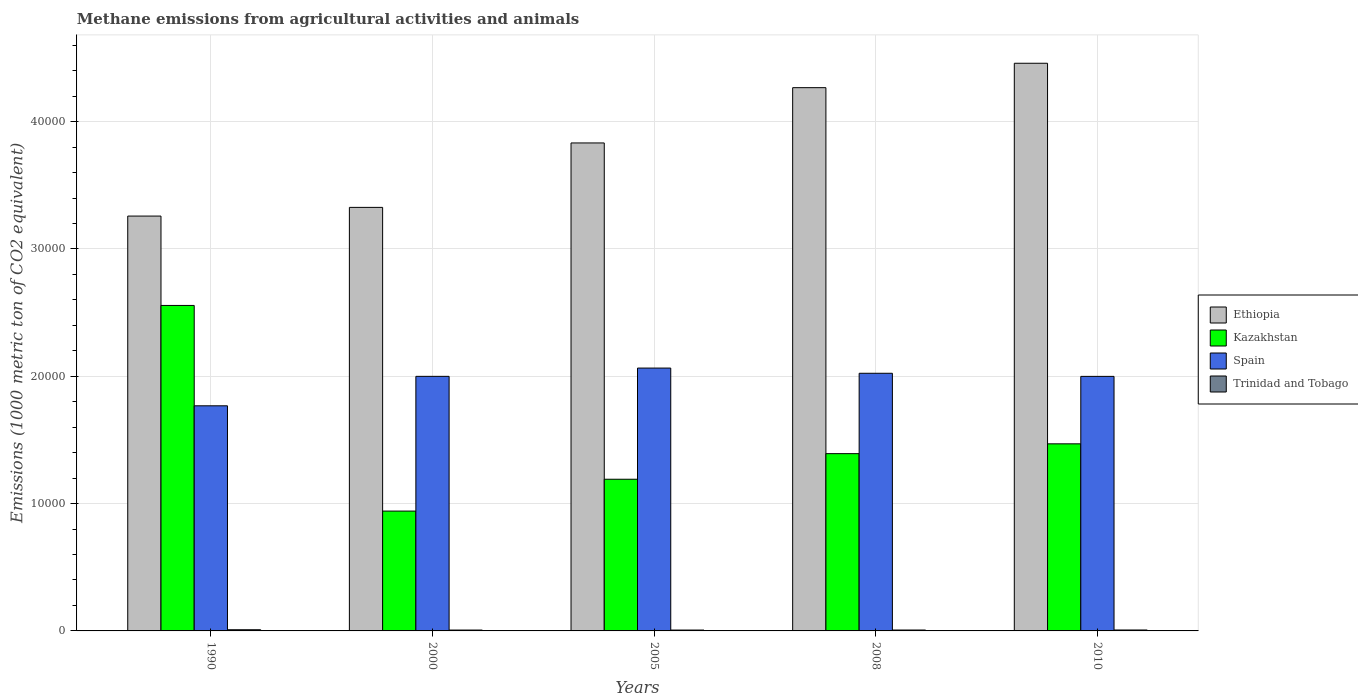Are the number of bars per tick equal to the number of legend labels?
Give a very brief answer. Yes. What is the label of the 5th group of bars from the left?
Offer a very short reply. 2010. What is the amount of methane emitted in Trinidad and Tobago in 2008?
Your answer should be very brief. 71. Across all years, what is the maximum amount of methane emitted in Spain?
Offer a terse response. 2.06e+04. Across all years, what is the minimum amount of methane emitted in Ethiopia?
Your response must be concise. 3.26e+04. In which year was the amount of methane emitted in Spain maximum?
Provide a succinct answer. 2005. In which year was the amount of methane emitted in Ethiopia minimum?
Make the answer very short. 1990. What is the total amount of methane emitted in Kazakhstan in the graph?
Your response must be concise. 7.55e+04. What is the difference between the amount of methane emitted in Kazakhstan in 1990 and that in 2000?
Your answer should be very brief. 1.62e+04. What is the difference between the amount of methane emitted in Spain in 2008 and the amount of methane emitted in Ethiopia in 2010?
Your response must be concise. -2.44e+04. What is the average amount of methane emitted in Ethiopia per year?
Give a very brief answer. 3.83e+04. In the year 2008, what is the difference between the amount of methane emitted in Trinidad and Tobago and amount of methane emitted in Spain?
Your answer should be very brief. -2.02e+04. What is the ratio of the amount of methane emitted in Spain in 2008 to that in 2010?
Your answer should be very brief. 1.01. Is the amount of methane emitted in Trinidad and Tobago in 2005 less than that in 2010?
Your answer should be compact. Yes. Is the difference between the amount of methane emitted in Trinidad and Tobago in 1990 and 2005 greater than the difference between the amount of methane emitted in Spain in 1990 and 2005?
Give a very brief answer. Yes. What is the difference between the highest and the second highest amount of methane emitted in Trinidad and Tobago?
Offer a very short reply. 19.3. What is the difference between the highest and the lowest amount of methane emitted in Kazakhstan?
Keep it short and to the point. 1.62e+04. Is the sum of the amount of methane emitted in Trinidad and Tobago in 2000 and 2010 greater than the maximum amount of methane emitted in Kazakhstan across all years?
Make the answer very short. No. Is it the case that in every year, the sum of the amount of methane emitted in Spain and amount of methane emitted in Ethiopia is greater than the sum of amount of methane emitted in Trinidad and Tobago and amount of methane emitted in Kazakhstan?
Make the answer very short. Yes. What does the 4th bar from the left in 2008 represents?
Provide a short and direct response. Trinidad and Tobago. What does the 2nd bar from the right in 1990 represents?
Provide a short and direct response. Spain. Is it the case that in every year, the sum of the amount of methane emitted in Kazakhstan and amount of methane emitted in Spain is greater than the amount of methane emitted in Trinidad and Tobago?
Offer a terse response. Yes. Are all the bars in the graph horizontal?
Offer a very short reply. No. What is the difference between two consecutive major ticks on the Y-axis?
Your answer should be compact. 10000. Are the values on the major ticks of Y-axis written in scientific E-notation?
Provide a succinct answer. No. Does the graph contain any zero values?
Offer a terse response. No. Does the graph contain grids?
Provide a short and direct response. Yes. How many legend labels are there?
Keep it short and to the point. 4. How are the legend labels stacked?
Provide a short and direct response. Vertical. What is the title of the graph?
Your answer should be compact. Methane emissions from agricultural activities and animals. What is the label or title of the X-axis?
Make the answer very short. Years. What is the label or title of the Y-axis?
Your answer should be very brief. Emissions (1000 metric ton of CO2 equivalent). What is the Emissions (1000 metric ton of CO2 equivalent) in Ethiopia in 1990?
Your response must be concise. 3.26e+04. What is the Emissions (1000 metric ton of CO2 equivalent) in Kazakhstan in 1990?
Your response must be concise. 2.56e+04. What is the Emissions (1000 metric ton of CO2 equivalent) in Spain in 1990?
Ensure brevity in your answer.  1.77e+04. What is the Emissions (1000 metric ton of CO2 equivalent) of Trinidad and Tobago in 1990?
Make the answer very short. 92.7. What is the Emissions (1000 metric ton of CO2 equivalent) of Ethiopia in 2000?
Your response must be concise. 3.33e+04. What is the Emissions (1000 metric ton of CO2 equivalent) in Kazakhstan in 2000?
Offer a very short reply. 9412.4. What is the Emissions (1000 metric ton of CO2 equivalent) of Spain in 2000?
Provide a succinct answer. 2.00e+04. What is the Emissions (1000 metric ton of CO2 equivalent) of Ethiopia in 2005?
Your answer should be very brief. 3.83e+04. What is the Emissions (1000 metric ton of CO2 equivalent) in Kazakhstan in 2005?
Keep it short and to the point. 1.19e+04. What is the Emissions (1000 metric ton of CO2 equivalent) in Spain in 2005?
Provide a succinct answer. 2.06e+04. What is the Emissions (1000 metric ton of CO2 equivalent) of Trinidad and Tobago in 2005?
Give a very brief answer. 68.1. What is the Emissions (1000 metric ton of CO2 equivalent) of Ethiopia in 2008?
Your response must be concise. 4.27e+04. What is the Emissions (1000 metric ton of CO2 equivalent) in Kazakhstan in 2008?
Offer a very short reply. 1.39e+04. What is the Emissions (1000 metric ton of CO2 equivalent) in Spain in 2008?
Keep it short and to the point. 2.02e+04. What is the Emissions (1000 metric ton of CO2 equivalent) of Ethiopia in 2010?
Make the answer very short. 4.46e+04. What is the Emissions (1000 metric ton of CO2 equivalent) of Kazakhstan in 2010?
Make the answer very short. 1.47e+04. What is the Emissions (1000 metric ton of CO2 equivalent) of Spain in 2010?
Provide a short and direct response. 2.00e+04. What is the Emissions (1000 metric ton of CO2 equivalent) of Trinidad and Tobago in 2010?
Your answer should be very brief. 73.4. Across all years, what is the maximum Emissions (1000 metric ton of CO2 equivalent) of Ethiopia?
Ensure brevity in your answer.  4.46e+04. Across all years, what is the maximum Emissions (1000 metric ton of CO2 equivalent) in Kazakhstan?
Ensure brevity in your answer.  2.56e+04. Across all years, what is the maximum Emissions (1000 metric ton of CO2 equivalent) of Spain?
Make the answer very short. 2.06e+04. Across all years, what is the maximum Emissions (1000 metric ton of CO2 equivalent) in Trinidad and Tobago?
Provide a succinct answer. 92.7. Across all years, what is the minimum Emissions (1000 metric ton of CO2 equivalent) of Ethiopia?
Offer a terse response. 3.26e+04. Across all years, what is the minimum Emissions (1000 metric ton of CO2 equivalent) in Kazakhstan?
Keep it short and to the point. 9412.4. Across all years, what is the minimum Emissions (1000 metric ton of CO2 equivalent) of Spain?
Your answer should be compact. 1.77e+04. Across all years, what is the minimum Emissions (1000 metric ton of CO2 equivalent) in Trinidad and Tobago?
Your answer should be compact. 68. What is the total Emissions (1000 metric ton of CO2 equivalent) of Ethiopia in the graph?
Provide a succinct answer. 1.91e+05. What is the total Emissions (1000 metric ton of CO2 equivalent) in Kazakhstan in the graph?
Make the answer very short. 7.55e+04. What is the total Emissions (1000 metric ton of CO2 equivalent) of Spain in the graph?
Your response must be concise. 9.86e+04. What is the total Emissions (1000 metric ton of CO2 equivalent) in Trinidad and Tobago in the graph?
Your answer should be very brief. 373.2. What is the difference between the Emissions (1000 metric ton of CO2 equivalent) in Ethiopia in 1990 and that in 2000?
Your response must be concise. -682.4. What is the difference between the Emissions (1000 metric ton of CO2 equivalent) in Kazakhstan in 1990 and that in 2000?
Your answer should be very brief. 1.62e+04. What is the difference between the Emissions (1000 metric ton of CO2 equivalent) in Spain in 1990 and that in 2000?
Your response must be concise. -2314.1. What is the difference between the Emissions (1000 metric ton of CO2 equivalent) in Trinidad and Tobago in 1990 and that in 2000?
Make the answer very short. 24.7. What is the difference between the Emissions (1000 metric ton of CO2 equivalent) in Ethiopia in 1990 and that in 2005?
Keep it short and to the point. -5743.4. What is the difference between the Emissions (1000 metric ton of CO2 equivalent) of Kazakhstan in 1990 and that in 2005?
Offer a very short reply. 1.37e+04. What is the difference between the Emissions (1000 metric ton of CO2 equivalent) in Spain in 1990 and that in 2005?
Give a very brief answer. -2964.8. What is the difference between the Emissions (1000 metric ton of CO2 equivalent) of Trinidad and Tobago in 1990 and that in 2005?
Your response must be concise. 24.6. What is the difference between the Emissions (1000 metric ton of CO2 equivalent) in Ethiopia in 1990 and that in 2008?
Keep it short and to the point. -1.01e+04. What is the difference between the Emissions (1000 metric ton of CO2 equivalent) of Kazakhstan in 1990 and that in 2008?
Provide a short and direct response. 1.16e+04. What is the difference between the Emissions (1000 metric ton of CO2 equivalent) in Spain in 1990 and that in 2008?
Give a very brief answer. -2555.9. What is the difference between the Emissions (1000 metric ton of CO2 equivalent) in Trinidad and Tobago in 1990 and that in 2008?
Offer a very short reply. 21.7. What is the difference between the Emissions (1000 metric ton of CO2 equivalent) in Ethiopia in 1990 and that in 2010?
Ensure brevity in your answer.  -1.20e+04. What is the difference between the Emissions (1000 metric ton of CO2 equivalent) of Kazakhstan in 1990 and that in 2010?
Your answer should be very brief. 1.09e+04. What is the difference between the Emissions (1000 metric ton of CO2 equivalent) of Spain in 1990 and that in 2010?
Ensure brevity in your answer.  -2311. What is the difference between the Emissions (1000 metric ton of CO2 equivalent) in Trinidad and Tobago in 1990 and that in 2010?
Make the answer very short. 19.3. What is the difference between the Emissions (1000 metric ton of CO2 equivalent) of Ethiopia in 2000 and that in 2005?
Your response must be concise. -5061. What is the difference between the Emissions (1000 metric ton of CO2 equivalent) in Kazakhstan in 2000 and that in 2005?
Make the answer very short. -2501.3. What is the difference between the Emissions (1000 metric ton of CO2 equivalent) of Spain in 2000 and that in 2005?
Your response must be concise. -650.7. What is the difference between the Emissions (1000 metric ton of CO2 equivalent) in Ethiopia in 2000 and that in 2008?
Offer a very short reply. -9403.7. What is the difference between the Emissions (1000 metric ton of CO2 equivalent) in Kazakhstan in 2000 and that in 2008?
Provide a succinct answer. -4512.5. What is the difference between the Emissions (1000 metric ton of CO2 equivalent) in Spain in 2000 and that in 2008?
Your answer should be very brief. -241.8. What is the difference between the Emissions (1000 metric ton of CO2 equivalent) in Ethiopia in 2000 and that in 2010?
Your answer should be very brief. -1.13e+04. What is the difference between the Emissions (1000 metric ton of CO2 equivalent) in Kazakhstan in 2000 and that in 2010?
Your response must be concise. -5283.1. What is the difference between the Emissions (1000 metric ton of CO2 equivalent) in Ethiopia in 2005 and that in 2008?
Ensure brevity in your answer.  -4342.7. What is the difference between the Emissions (1000 metric ton of CO2 equivalent) in Kazakhstan in 2005 and that in 2008?
Your answer should be very brief. -2011.2. What is the difference between the Emissions (1000 metric ton of CO2 equivalent) of Spain in 2005 and that in 2008?
Your answer should be very brief. 408.9. What is the difference between the Emissions (1000 metric ton of CO2 equivalent) in Ethiopia in 2005 and that in 2010?
Your answer should be very brief. -6259.7. What is the difference between the Emissions (1000 metric ton of CO2 equivalent) of Kazakhstan in 2005 and that in 2010?
Your response must be concise. -2781.8. What is the difference between the Emissions (1000 metric ton of CO2 equivalent) of Spain in 2005 and that in 2010?
Give a very brief answer. 653.8. What is the difference between the Emissions (1000 metric ton of CO2 equivalent) in Trinidad and Tobago in 2005 and that in 2010?
Make the answer very short. -5.3. What is the difference between the Emissions (1000 metric ton of CO2 equivalent) in Ethiopia in 2008 and that in 2010?
Ensure brevity in your answer.  -1917. What is the difference between the Emissions (1000 metric ton of CO2 equivalent) in Kazakhstan in 2008 and that in 2010?
Offer a terse response. -770.6. What is the difference between the Emissions (1000 metric ton of CO2 equivalent) of Spain in 2008 and that in 2010?
Your response must be concise. 244.9. What is the difference between the Emissions (1000 metric ton of CO2 equivalent) of Trinidad and Tobago in 2008 and that in 2010?
Give a very brief answer. -2.4. What is the difference between the Emissions (1000 metric ton of CO2 equivalent) in Ethiopia in 1990 and the Emissions (1000 metric ton of CO2 equivalent) in Kazakhstan in 2000?
Your response must be concise. 2.32e+04. What is the difference between the Emissions (1000 metric ton of CO2 equivalent) of Ethiopia in 1990 and the Emissions (1000 metric ton of CO2 equivalent) of Spain in 2000?
Ensure brevity in your answer.  1.26e+04. What is the difference between the Emissions (1000 metric ton of CO2 equivalent) of Ethiopia in 1990 and the Emissions (1000 metric ton of CO2 equivalent) of Trinidad and Tobago in 2000?
Provide a succinct answer. 3.25e+04. What is the difference between the Emissions (1000 metric ton of CO2 equivalent) in Kazakhstan in 1990 and the Emissions (1000 metric ton of CO2 equivalent) in Spain in 2000?
Provide a succinct answer. 5569.7. What is the difference between the Emissions (1000 metric ton of CO2 equivalent) of Kazakhstan in 1990 and the Emissions (1000 metric ton of CO2 equivalent) of Trinidad and Tobago in 2000?
Your answer should be very brief. 2.55e+04. What is the difference between the Emissions (1000 metric ton of CO2 equivalent) of Spain in 1990 and the Emissions (1000 metric ton of CO2 equivalent) of Trinidad and Tobago in 2000?
Your answer should be very brief. 1.76e+04. What is the difference between the Emissions (1000 metric ton of CO2 equivalent) of Ethiopia in 1990 and the Emissions (1000 metric ton of CO2 equivalent) of Kazakhstan in 2005?
Your response must be concise. 2.07e+04. What is the difference between the Emissions (1000 metric ton of CO2 equivalent) in Ethiopia in 1990 and the Emissions (1000 metric ton of CO2 equivalent) in Spain in 2005?
Your response must be concise. 1.19e+04. What is the difference between the Emissions (1000 metric ton of CO2 equivalent) of Ethiopia in 1990 and the Emissions (1000 metric ton of CO2 equivalent) of Trinidad and Tobago in 2005?
Your response must be concise. 3.25e+04. What is the difference between the Emissions (1000 metric ton of CO2 equivalent) of Kazakhstan in 1990 and the Emissions (1000 metric ton of CO2 equivalent) of Spain in 2005?
Provide a short and direct response. 4919. What is the difference between the Emissions (1000 metric ton of CO2 equivalent) of Kazakhstan in 1990 and the Emissions (1000 metric ton of CO2 equivalent) of Trinidad and Tobago in 2005?
Your response must be concise. 2.55e+04. What is the difference between the Emissions (1000 metric ton of CO2 equivalent) of Spain in 1990 and the Emissions (1000 metric ton of CO2 equivalent) of Trinidad and Tobago in 2005?
Provide a short and direct response. 1.76e+04. What is the difference between the Emissions (1000 metric ton of CO2 equivalent) in Ethiopia in 1990 and the Emissions (1000 metric ton of CO2 equivalent) in Kazakhstan in 2008?
Keep it short and to the point. 1.87e+04. What is the difference between the Emissions (1000 metric ton of CO2 equivalent) in Ethiopia in 1990 and the Emissions (1000 metric ton of CO2 equivalent) in Spain in 2008?
Offer a very short reply. 1.23e+04. What is the difference between the Emissions (1000 metric ton of CO2 equivalent) of Ethiopia in 1990 and the Emissions (1000 metric ton of CO2 equivalent) of Trinidad and Tobago in 2008?
Give a very brief answer. 3.25e+04. What is the difference between the Emissions (1000 metric ton of CO2 equivalent) in Kazakhstan in 1990 and the Emissions (1000 metric ton of CO2 equivalent) in Spain in 2008?
Your response must be concise. 5327.9. What is the difference between the Emissions (1000 metric ton of CO2 equivalent) in Kazakhstan in 1990 and the Emissions (1000 metric ton of CO2 equivalent) in Trinidad and Tobago in 2008?
Provide a short and direct response. 2.55e+04. What is the difference between the Emissions (1000 metric ton of CO2 equivalent) of Spain in 1990 and the Emissions (1000 metric ton of CO2 equivalent) of Trinidad and Tobago in 2008?
Keep it short and to the point. 1.76e+04. What is the difference between the Emissions (1000 metric ton of CO2 equivalent) of Ethiopia in 1990 and the Emissions (1000 metric ton of CO2 equivalent) of Kazakhstan in 2010?
Make the answer very short. 1.79e+04. What is the difference between the Emissions (1000 metric ton of CO2 equivalent) in Ethiopia in 1990 and the Emissions (1000 metric ton of CO2 equivalent) in Spain in 2010?
Provide a short and direct response. 1.26e+04. What is the difference between the Emissions (1000 metric ton of CO2 equivalent) in Ethiopia in 1990 and the Emissions (1000 metric ton of CO2 equivalent) in Trinidad and Tobago in 2010?
Offer a very short reply. 3.25e+04. What is the difference between the Emissions (1000 metric ton of CO2 equivalent) of Kazakhstan in 1990 and the Emissions (1000 metric ton of CO2 equivalent) of Spain in 2010?
Provide a short and direct response. 5572.8. What is the difference between the Emissions (1000 metric ton of CO2 equivalent) in Kazakhstan in 1990 and the Emissions (1000 metric ton of CO2 equivalent) in Trinidad and Tobago in 2010?
Offer a terse response. 2.55e+04. What is the difference between the Emissions (1000 metric ton of CO2 equivalent) in Spain in 1990 and the Emissions (1000 metric ton of CO2 equivalent) in Trinidad and Tobago in 2010?
Offer a very short reply. 1.76e+04. What is the difference between the Emissions (1000 metric ton of CO2 equivalent) of Ethiopia in 2000 and the Emissions (1000 metric ton of CO2 equivalent) of Kazakhstan in 2005?
Your response must be concise. 2.14e+04. What is the difference between the Emissions (1000 metric ton of CO2 equivalent) in Ethiopia in 2000 and the Emissions (1000 metric ton of CO2 equivalent) in Spain in 2005?
Offer a terse response. 1.26e+04. What is the difference between the Emissions (1000 metric ton of CO2 equivalent) of Ethiopia in 2000 and the Emissions (1000 metric ton of CO2 equivalent) of Trinidad and Tobago in 2005?
Offer a very short reply. 3.32e+04. What is the difference between the Emissions (1000 metric ton of CO2 equivalent) of Kazakhstan in 2000 and the Emissions (1000 metric ton of CO2 equivalent) of Spain in 2005?
Your answer should be very brief. -1.12e+04. What is the difference between the Emissions (1000 metric ton of CO2 equivalent) in Kazakhstan in 2000 and the Emissions (1000 metric ton of CO2 equivalent) in Trinidad and Tobago in 2005?
Provide a succinct answer. 9344.3. What is the difference between the Emissions (1000 metric ton of CO2 equivalent) of Spain in 2000 and the Emissions (1000 metric ton of CO2 equivalent) of Trinidad and Tobago in 2005?
Your answer should be compact. 1.99e+04. What is the difference between the Emissions (1000 metric ton of CO2 equivalent) of Ethiopia in 2000 and the Emissions (1000 metric ton of CO2 equivalent) of Kazakhstan in 2008?
Provide a succinct answer. 1.93e+04. What is the difference between the Emissions (1000 metric ton of CO2 equivalent) of Ethiopia in 2000 and the Emissions (1000 metric ton of CO2 equivalent) of Spain in 2008?
Give a very brief answer. 1.30e+04. What is the difference between the Emissions (1000 metric ton of CO2 equivalent) in Ethiopia in 2000 and the Emissions (1000 metric ton of CO2 equivalent) in Trinidad and Tobago in 2008?
Your response must be concise. 3.32e+04. What is the difference between the Emissions (1000 metric ton of CO2 equivalent) in Kazakhstan in 2000 and the Emissions (1000 metric ton of CO2 equivalent) in Spain in 2008?
Your answer should be very brief. -1.08e+04. What is the difference between the Emissions (1000 metric ton of CO2 equivalent) of Kazakhstan in 2000 and the Emissions (1000 metric ton of CO2 equivalent) of Trinidad and Tobago in 2008?
Your answer should be very brief. 9341.4. What is the difference between the Emissions (1000 metric ton of CO2 equivalent) of Spain in 2000 and the Emissions (1000 metric ton of CO2 equivalent) of Trinidad and Tobago in 2008?
Give a very brief answer. 1.99e+04. What is the difference between the Emissions (1000 metric ton of CO2 equivalent) of Ethiopia in 2000 and the Emissions (1000 metric ton of CO2 equivalent) of Kazakhstan in 2010?
Offer a terse response. 1.86e+04. What is the difference between the Emissions (1000 metric ton of CO2 equivalent) of Ethiopia in 2000 and the Emissions (1000 metric ton of CO2 equivalent) of Spain in 2010?
Ensure brevity in your answer.  1.33e+04. What is the difference between the Emissions (1000 metric ton of CO2 equivalent) in Ethiopia in 2000 and the Emissions (1000 metric ton of CO2 equivalent) in Trinidad and Tobago in 2010?
Make the answer very short. 3.32e+04. What is the difference between the Emissions (1000 metric ton of CO2 equivalent) in Kazakhstan in 2000 and the Emissions (1000 metric ton of CO2 equivalent) in Spain in 2010?
Your answer should be compact. -1.06e+04. What is the difference between the Emissions (1000 metric ton of CO2 equivalent) of Kazakhstan in 2000 and the Emissions (1000 metric ton of CO2 equivalent) of Trinidad and Tobago in 2010?
Provide a succinct answer. 9339. What is the difference between the Emissions (1000 metric ton of CO2 equivalent) of Spain in 2000 and the Emissions (1000 metric ton of CO2 equivalent) of Trinidad and Tobago in 2010?
Provide a short and direct response. 1.99e+04. What is the difference between the Emissions (1000 metric ton of CO2 equivalent) in Ethiopia in 2005 and the Emissions (1000 metric ton of CO2 equivalent) in Kazakhstan in 2008?
Ensure brevity in your answer.  2.44e+04. What is the difference between the Emissions (1000 metric ton of CO2 equivalent) in Ethiopia in 2005 and the Emissions (1000 metric ton of CO2 equivalent) in Spain in 2008?
Give a very brief answer. 1.81e+04. What is the difference between the Emissions (1000 metric ton of CO2 equivalent) in Ethiopia in 2005 and the Emissions (1000 metric ton of CO2 equivalent) in Trinidad and Tobago in 2008?
Offer a terse response. 3.83e+04. What is the difference between the Emissions (1000 metric ton of CO2 equivalent) in Kazakhstan in 2005 and the Emissions (1000 metric ton of CO2 equivalent) in Spain in 2008?
Your answer should be compact. -8324.8. What is the difference between the Emissions (1000 metric ton of CO2 equivalent) of Kazakhstan in 2005 and the Emissions (1000 metric ton of CO2 equivalent) of Trinidad and Tobago in 2008?
Your response must be concise. 1.18e+04. What is the difference between the Emissions (1000 metric ton of CO2 equivalent) of Spain in 2005 and the Emissions (1000 metric ton of CO2 equivalent) of Trinidad and Tobago in 2008?
Give a very brief answer. 2.06e+04. What is the difference between the Emissions (1000 metric ton of CO2 equivalent) in Ethiopia in 2005 and the Emissions (1000 metric ton of CO2 equivalent) in Kazakhstan in 2010?
Your answer should be very brief. 2.36e+04. What is the difference between the Emissions (1000 metric ton of CO2 equivalent) of Ethiopia in 2005 and the Emissions (1000 metric ton of CO2 equivalent) of Spain in 2010?
Provide a succinct answer. 1.83e+04. What is the difference between the Emissions (1000 metric ton of CO2 equivalent) of Ethiopia in 2005 and the Emissions (1000 metric ton of CO2 equivalent) of Trinidad and Tobago in 2010?
Provide a succinct answer. 3.83e+04. What is the difference between the Emissions (1000 metric ton of CO2 equivalent) of Kazakhstan in 2005 and the Emissions (1000 metric ton of CO2 equivalent) of Spain in 2010?
Provide a short and direct response. -8079.9. What is the difference between the Emissions (1000 metric ton of CO2 equivalent) of Kazakhstan in 2005 and the Emissions (1000 metric ton of CO2 equivalent) of Trinidad and Tobago in 2010?
Your response must be concise. 1.18e+04. What is the difference between the Emissions (1000 metric ton of CO2 equivalent) of Spain in 2005 and the Emissions (1000 metric ton of CO2 equivalent) of Trinidad and Tobago in 2010?
Your response must be concise. 2.06e+04. What is the difference between the Emissions (1000 metric ton of CO2 equivalent) of Ethiopia in 2008 and the Emissions (1000 metric ton of CO2 equivalent) of Kazakhstan in 2010?
Offer a terse response. 2.80e+04. What is the difference between the Emissions (1000 metric ton of CO2 equivalent) in Ethiopia in 2008 and the Emissions (1000 metric ton of CO2 equivalent) in Spain in 2010?
Your answer should be very brief. 2.27e+04. What is the difference between the Emissions (1000 metric ton of CO2 equivalent) in Ethiopia in 2008 and the Emissions (1000 metric ton of CO2 equivalent) in Trinidad and Tobago in 2010?
Give a very brief answer. 4.26e+04. What is the difference between the Emissions (1000 metric ton of CO2 equivalent) of Kazakhstan in 2008 and the Emissions (1000 metric ton of CO2 equivalent) of Spain in 2010?
Ensure brevity in your answer.  -6068.7. What is the difference between the Emissions (1000 metric ton of CO2 equivalent) of Kazakhstan in 2008 and the Emissions (1000 metric ton of CO2 equivalent) of Trinidad and Tobago in 2010?
Make the answer very short. 1.39e+04. What is the difference between the Emissions (1000 metric ton of CO2 equivalent) in Spain in 2008 and the Emissions (1000 metric ton of CO2 equivalent) in Trinidad and Tobago in 2010?
Ensure brevity in your answer.  2.02e+04. What is the average Emissions (1000 metric ton of CO2 equivalent) of Ethiopia per year?
Make the answer very short. 3.83e+04. What is the average Emissions (1000 metric ton of CO2 equivalent) in Kazakhstan per year?
Ensure brevity in your answer.  1.51e+04. What is the average Emissions (1000 metric ton of CO2 equivalent) in Spain per year?
Provide a succinct answer. 1.97e+04. What is the average Emissions (1000 metric ton of CO2 equivalent) of Trinidad and Tobago per year?
Your answer should be very brief. 74.64. In the year 1990, what is the difference between the Emissions (1000 metric ton of CO2 equivalent) in Ethiopia and Emissions (1000 metric ton of CO2 equivalent) in Kazakhstan?
Your answer should be compact. 7020.1. In the year 1990, what is the difference between the Emissions (1000 metric ton of CO2 equivalent) of Ethiopia and Emissions (1000 metric ton of CO2 equivalent) of Spain?
Make the answer very short. 1.49e+04. In the year 1990, what is the difference between the Emissions (1000 metric ton of CO2 equivalent) of Ethiopia and Emissions (1000 metric ton of CO2 equivalent) of Trinidad and Tobago?
Offer a very short reply. 3.25e+04. In the year 1990, what is the difference between the Emissions (1000 metric ton of CO2 equivalent) of Kazakhstan and Emissions (1000 metric ton of CO2 equivalent) of Spain?
Ensure brevity in your answer.  7883.8. In the year 1990, what is the difference between the Emissions (1000 metric ton of CO2 equivalent) in Kazakhstan and Emissions (1000 metric ton of CO2 equivalent) in Trinidad and Tobago?
Provide a short and direct response. 2.55e+04. In the year 1990, what is the difference between the Emissions (1000 metric ton of CO2 equivalent) in Spain and Emissions (1000 metric ton of CO2 equivalent) in Trinidad and Tobago?
Provide a succinct answer. 1.76e+04. In the year 2000, what is the difference between the Emissions (1000 metric ton of CO2 equivalent) of Ethiopia and Emissions (1000 metric ton of CO2 equivalent) of Kazakhstan?
Your response must be concise. 2.39e+04. In the year 2000, what is the difference between the Emissions (1000 metric ton of CO2 equivalent) in Ethiopia and Emissions (1000 metric ton of CO2 equivalent) in Spain?
Provide a succinct answer. 1.33e+04. In the year 2000, what is the difference between the Emissions (1000 metric ton of CO2 equivalent) in Ethiopia and Emissions (1000 metric ton of CO2 equivalent) in Trinidad and Tobago?
Make the answer very short. 3.32e+04. In the year 2000, what is the difference between the Emissions (1000 metric ton of CO2 equivalent) in Kazakhstan and Emissions (1000 metric ton of CO2 equivalent) in Spain?
Give a very brief answer. -1.06e+04. In the year 2000, what is the difference between the Emissions (1000 metric ton of CO2 equivalent) of Kazakhstan and Emissions (1000 metric ton of CO2 equivalent) of Trinidad and Tobago?
Your answer should be compact. 9344.4. In the year 2000, what is the difference between the Emissions (1000 metric ton of CO2 equivalent) of Spain and Emissions (1000 metric ton of CO2 equivalent) of Trinidad and Tobago?
Provide a succinct answer. 1.99e+04. In the year 2005, what is the difference between the Emissions (1000 metric ton of CO2 equivalent) in Ethiopia and Emissions (1000 metric ton of CO2 equivalent) in Kazakhstan?
Provide a succinct answer. 2.64e+04. In the year 2005, what is the difference between the Emissions (1000 metric ton of CO2 equivalent) in Ethiopia and Emissions (1000 metric ton of CO2 equivalent) in Spain?
Your response must be concise. 1.77e+04. In the year 2005, what is the difference between the Emissions (1000 metric ton of CO2 equivalent) in Ethiopia and Emissions (1000 metric ton of CO2 equivalent) in Trinidad and Tobago?
Provide a short and direct response. 3.83e+04. In the year 2005, what is the difference between the Emissions (1000 metric ton of CO2 equivalent) in Kazakhstan and Emissions (1000 metric ton of CO2 equivalent) in Spain?
Your response must be concise. -8733.7. In the year 2005, what is the difference between the Emissions (1000 metric ton of CO2 equivalent) of Kazakhstan and Emissions (1000 metric ton of CO2 equivalent) of Trinidad and Tobago?
Provide a succinct answer. 1.18e+04. In the year 2005, what is the difference between the Emissions (1000 metric ton of CO2 equivalent) in Spain and Emissions (1000 metric ton of CO2 equivalent) in Trinidad and Tobago?
Offer a very short reply. 2.06e+04. In the year 2008, what is the difference between the Emissions (1000 metric ton of CO2 equivalent) of Ethiopia and Emissions (1000 metric ton of CO2 equivalent) of Kazakhstan?
Offer a terse response. 2.87e+04. In the year 2008, what is the difference between the Emissions (1000 metric ton of CO2 equivalent) of Ethiopia and Emissions (1000 metric ton of CO2 equivalent) of Spain?
Offer a very short reply. 2.24e+04. In the year 2008, what is the difference between the Emissions (1000 metric ton of CO2 equivalent) in Ethiopia and Emissions (1000 metric ton of CO2 equivalent) in Trinidad and Tobago?
Your response must be concise. 4.26e+04. In the year 2008, what is the difference between the Emissions (1000 metric ton of CO2 equivalent) of Kazakhstan and Emissions (1000 metric ton of CO2 equivalent) of Spain?
Ensure brevity in your answer.  -6313.6. In the year 2008, what is the difference between the Emissions (1000 metric ton of CO2 equivalent) in Kazakhstan and Emissions (1000 metric ton of CO2 equivalent) in Trinidad and Tobago?
Give a very brief answer. 1.39e+04. In the year 2008, what is the difference between the Emissions (1000 metric ton of CO2 equivalent) in Spain and Emissions (1000 metric ton of CO2 equivalent) in Trinidad and Tobago?
Your answer should be very brief. 2.02e+04. In the year 2010, what is the difference between the Emissions (1000 metric ton of CO2 equivalent) in Ethiopia and Emissions (1000 metric ton of CO2 equivalent) in Kazakhstan?
Give a very brief answer. 2.99e+04. In the year 2010, what is the difference between the Emissions (1000 metric ton of CO2 equivalent) of Ethiopia and Emissions (1000 metric ton of CO2 equivalent) of Spain?
Keep it short and to the point. 2.46e+04. In the year 2010, what is the difference between the Emissions (1000 metric ton of CO2 equivalent) of Ethiopia and Emissions (1000 metric ton of CO2 equivalent) of Trinidad and Tobago?
Your answer should be compact. 4.45e+04. In the year 2010, what is the difference between the Emissions (1000 metric ton of CO2 equivalent) in Kazakhstan and Emissions (1000 metric ton of CO2 equivalent) in Spain?
Make the answer very short. -5298.1. In the year 2010, what is the difference between the Emissions (1000 metric ton of CO2 equivalent) of Kazakhstan and Emissions (1000 metric ton of CO2 equivalent) of Trinidad and Tobago?
Make the answer very short. 1.46e+04. In the year 2010, what is the difference between the Emissions (1000 metric ton of CO2 equivalent) of Spain and Emissions (1000 metric ton of CO2 equivalent) of Trinidad and Tobago?
Offer a very short reply. 1.99e+04. What is the ratio of the Emissions (1000 metric ton of CO2 equivalent) of Ethiopia in 1990 to that in 2000?
Provide a succinct answer. 0.98. What is the ratio of the Emissions (1000 metric ton of CO2 equivalent) of Kazakhstan in 1990 to that in 2000?
Keep it short and to the point. 2.72. What is the ratio of the Emissions (1000 metric ton of CO2 equivalent) of Spain in 1990 to that in 2000?
Offer a terse response. 0.88. What is the ratio of the Emissions (1000 metric ton of CO2 equivalent) in Trinidad and Tobago in 1990 to that in 2000?
Offer a very short reply. 1.36. What is the ratio of the Emissions (1000 metric ton of CO2 equivalent) in Ethiopia in 1990 to that in 2005?
Make the answer very short. 0.85. What is the ratio of the Emissions (1000 metric ton of CO2 equivalent) in Kazakhstan in 1990 to that in 2005?
Provide a succinct answer. 2.15. What is the ratio of the Emissions (1000 metric ton of CO2 equivalent) in Spain in 1990 to that in 2005?
Your response must be concise. 0.86. What is the ratio of the Emissions (1000 metric ton of CO2 equivalent) in Trinidad and Tobago in 1990 to that in 2005?
Provide a succinct answer. 1.36. What is the ratio of the Emissions (1000 metric ton of CO2 equivalent) of Ethiopia in 1990 to that in 2008?
Give a very brief answer. 0.76. What is the ratio of the Emissions (1000 metric ton of CO2 equivalent) in Kazakhstan in 1990 to that in 2008?
Ensure brevity in your answer.  1.84. What is the ratio of the Emissions (1000 metric ton of CO2 equivalent) in Spain in 1990 to that in 2008?
Your response must be concise. 0.87. What is the ratio of the Emissions (1000 metric ton of CO2 equivalent) of Trinidad and Tobago in 1990 to that in 2008?
Give a very brief answer. 1.31. What is the ratio of the Emissions (1000 metric ton of CO2 equivalent) in Ethiopia in 1990 to that in 2010?
Offer a very short reply. 0.73. What is the ratio of the Emissions (1000 metric ton of CO2 equivalent) in Kazakhstan in 1990 to that in 2010?
Give a very brief answer. 1.74. What is the ratio of the Emissions (1000 metric ton of CO2 equivalent) in Spain in 1990 to that in 2010?
Keep it short and to the point. 0.88. What is the ratio of the Emissions (1000 metric ton of CO2 equivalent) in Trinidad and Tobago in 1990 to that in 2010?
Your answer should be compact. 1.26. What is the ratio of the Emissions (1000 metric ton of CO2 equivalent) in Ethiopia in 2000 to that in 2005?
Make the answer very short. 0.87. What is the ratio of the Emissions (1000 metric ton of CO2 equivalent) in Kazakhstan in 2000 to that in 2005?
Your answer should be very brief. 0.79. What is the ratio of the Emissions (1000 metric ton of CO2 equivalent) of Spain in 2000 to that in 2005?
Keep it short and to the point. 0.97. What is the ratio of the Emissions (1000 metric ton of CO2 equivalent) in Trinidad and Tobago in 2000 to that in 2005?
Make the answer very short. 1. What is the ratio of the Emissions (1000 metric ton of CO2 equivalent) in Ethiopia in 2000 to that in 2008?
Keep it short and to the point. 0.78. What is the ratio of the Emissions (1000 metric ton of CO2 equivalent) of Kazakhstan in 2000 to that in 2008?
Provide a succinct answer. 0.68. What is the ratio of the Emissions (1000 metric ton of CO2 equivalent) of Trinidad and Tobago in 2000 to that in 2008?
Offer a terse response. 0.96. What is the ratio of the Emissions (1000 metric ton of CO2 equivalent) in Ethiopia in 2000 to that in 2010?
Your response must be concise. 0.75. What is the ratio of the Emissions (1000 metric ton of CO2 equivalent) in Kazakhstan in 2000 to that in 2010?
Make the answer very short. 0.64. What is the ratio of the Emissions (1000 metric ton of CO2 equivalent) in Spain in 2000 to that in 2010?
Your response must be concise. 1. What is the ratio of the Emissions (1000 metric ton of CO2 equivalent) of Trinidad and Tobago in 2000 to that in 2010?
Give a very brief answer. 0.93. What is the ratio of the Emissions (1000 metric ton of CO2 equivalent) of Ethiopia in 2005 to that in 2008?
Provide a succinct answer. 0.9. What is the ratio of the Emissions (1000 metric ton of CO2 equivalent) in Kazakhstan in 2005 to that in 2008?
Your answer should be compact. 0.86. What is the ratio of the Emissions (1000 metric ton of CO2 equivalent) in Spain in 2005 to that in 2008?
Offer a terse response. 1.02. What is the ratio of the Emissions (1000 metric ton of CO2 equivalent) in Trinidad and Tobago in 2005 to that in 2008?
Offer a terse response. 0.96. What is the ratio of the Emissions (1000 metric ton of CO2 equivalent) in Ethiopia in 2005 to that in 2010?
Make the answer very short. 0.86. What is the ratio of the Emissions (1000 metric ton of CO2 equivalent) of Kazakhstan in 2005 to that in 2010?
Keep it short and to the point. 0.81. What is the ratio of the Emissions (1000 metric ton of CO2 equivalent) in Spain in 2005 to that in 2010?
Your answer should be very brief. 1.03. What is the ratio of the Emissions (1000 metric ton of CO2 equivalent) in Trinidad and Tobago in 2005 to that in 2010?
Provide a succinct answer. 0.93. What is the ratio of the Emissions (1000 metric ton of CO2 equivalent) of Ethiopia in 2008 to that in 2010?
Offer a very short reply. 0.96. What is the ratio of the Emissions (1000 metric ton of CO2 equivalent) of Kazakhstan in 2008 to that in 2010?
Provide a short and direct response. 0.95. What is the ratio of the Emissions (1000 metric ton of CO2 equivalent) in Spain in 2008 to that in 2010?
Keep it short and to the point. 1.01. What is the ratio of the Emissions (1000 metric ton of CO2 equivalent) of Trinidad and Tobago in 2008 to that in 2010?
Your answer should be very brief. 0.97. What is the difference between the highest and the second highest Emissions (1000 metric ton of CO2 equivalent) of Ethiopia?
Make the answer very short. 1917. What is the difference between the highest and the second highest Emissions (1000 metric ton of CO2 equivalent) in Kazakhstan?
Provide a short and direct response. 1.09e+04. What is the difference between the highest and the second highest Emissions (1000 metric ton of CO2 equivalent) in Spain?
Offer a terse response. 408.9. What is the difference between the highest and the second highest Emissions (1000 metric ton of CO2 equivalent) of Trinidad and Tobago?
Give a very brief answer. 19.3. What is the difference between the highest and the lowest Emissions (1000 metric ton of CO2 equivalent) in Ethiopia?
Ensure brevity in your answer.  1.20e+04. What is the difference between the highest and the lowest Emissions (1000 metric ton of CO2 equivalent) in Kazakhstan?
Offer a very short reply. 1.62e+04. What is the difference between the highest and the lowest Emissions (1000 metric ton of CO2 equivalent) of Spain?
Give a very brief answer. 2964.8. What is the difference between the highest and the lowest Emissions (1000 metric ton of CO2 equivalent) of Trinidad and Tobago?
Keep it short and to the point. 24.7. 